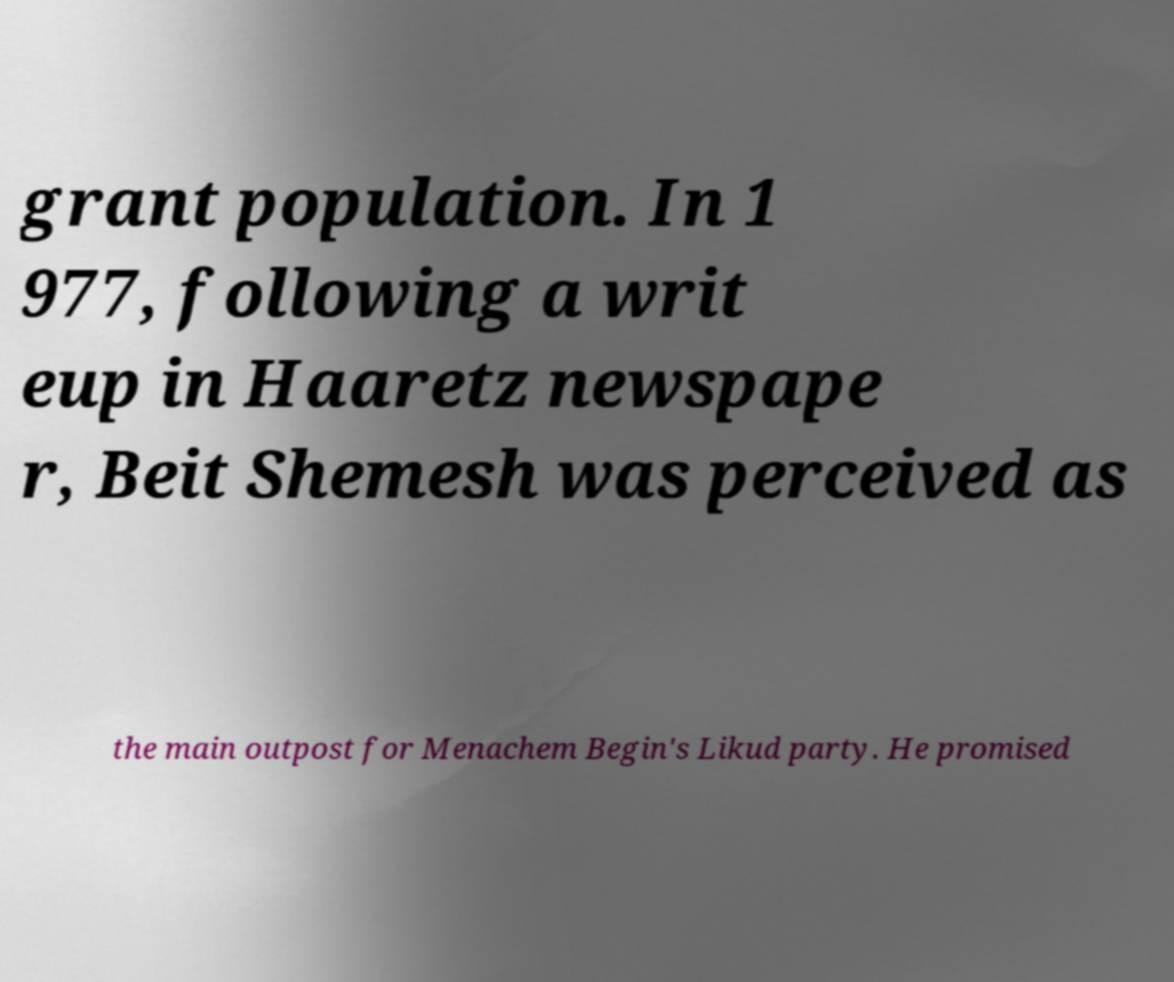What messages or text are displayed in this image? I need them in a readable, typed format. grant population. In 1 977, following a writ eup in Haaretz newspape r, Beit Shemesh was perceived as the main outpost for Menachem Begin's Likud party. He promised 